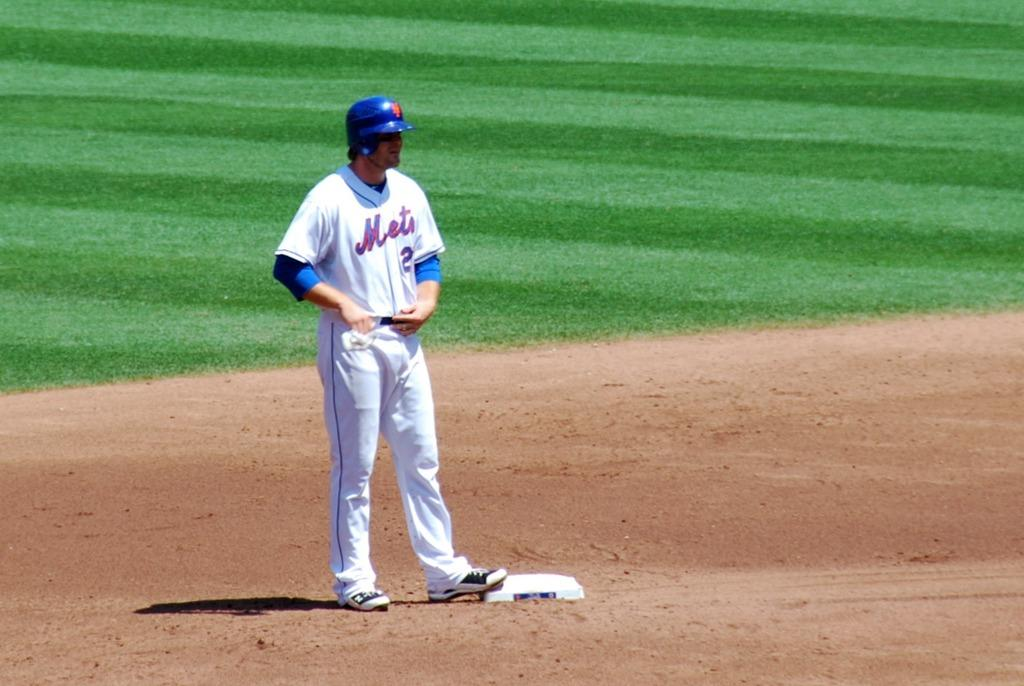<image>
Present a compact description of the photo's key features. Mets baseball player on second base, wearing a #2 Jersey. 